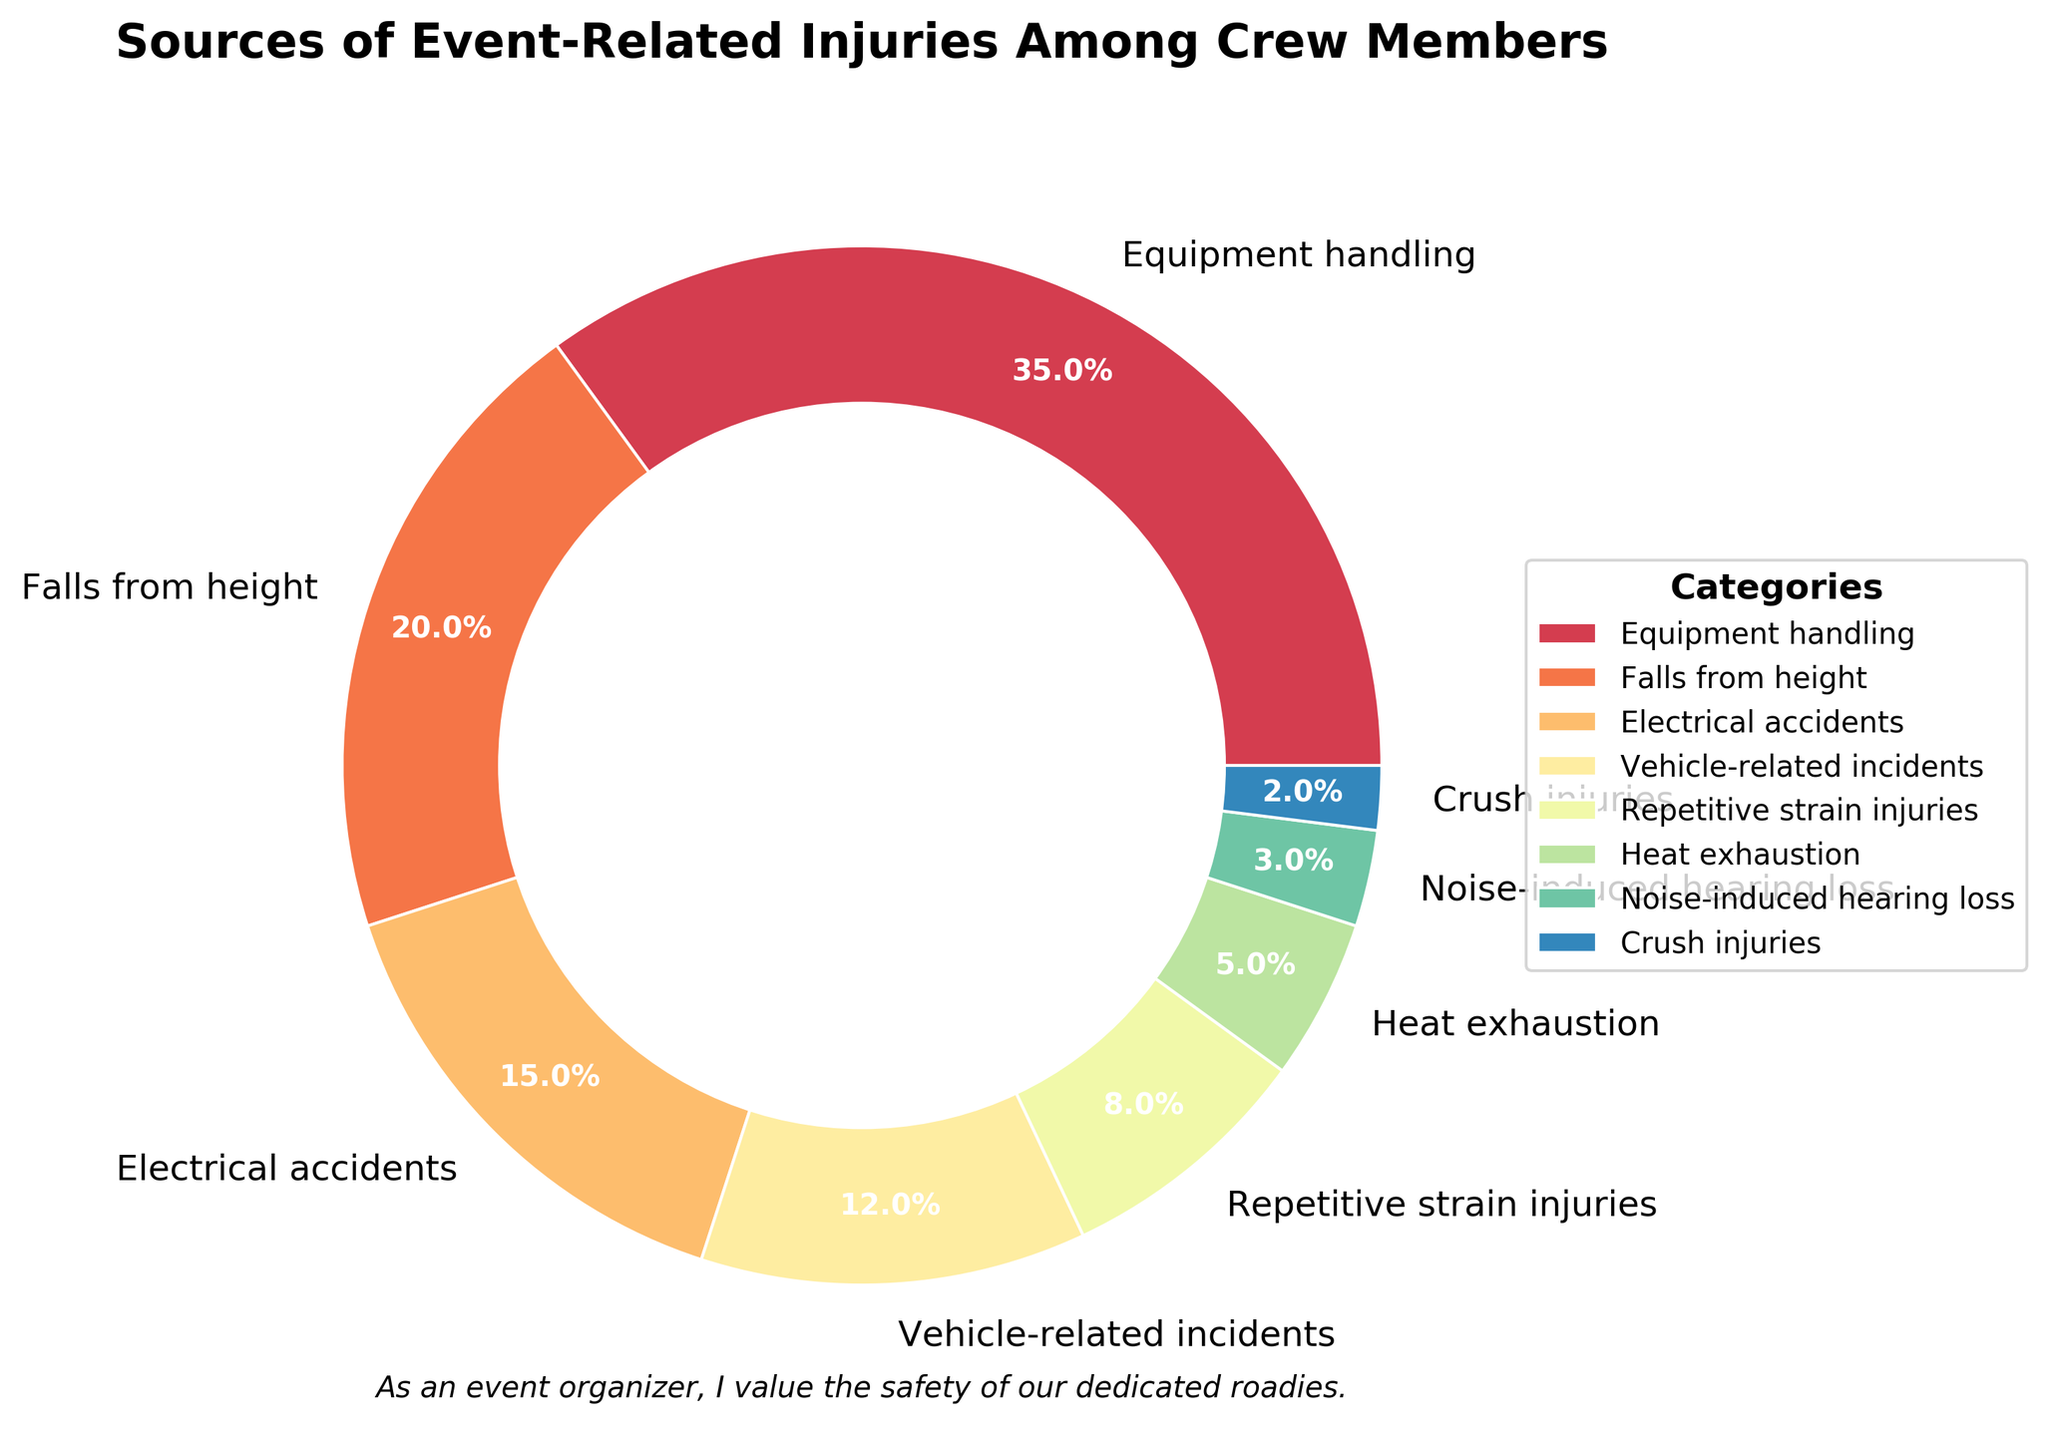What is the category with the highest percentage of event-related injuries among crew members? The pie chart shows that "Equipment handling" has the largest wedge, labeled with 35%. Thus, this category has the highest percentage of injuries.
Answer: Equipment handling Which two categories have the smallest percentages? By visually inspecting the pie chart, the wedges for "Crush injuries" and "Noise-induced hearing loss" are the smallest. They are labeled with 2% and 3% respectively, making them the smallest categories.
Answer: Crush injuries and Noise-induced hearing loss What is the combined percentage of "Falls from height" and "Electrical accidents"? The pie chart shows "Falls from height" at 20% and "Electrical accidents" at 15%. Adding these percentages gives 20% + 15% = 35%.
Answer: 35% Which category has a smaller percentage: "Heat exhaustion" or "Vehicle-related incidents"? Comparing the sizes of the wedges labeled "Heat exhaustion" and "Vehicle-related incidents," we see "Heat exhaustion" is 5% and "Vehicle-related incidents" is 12%. Therefore, "Heat exhaustion" has a smaller percentage.
Answer: Heat exhaustion What visual feature is used to separate each category in the pie chart? The pie chart uses white lines (edges) to separate each wedge or section. This feature clearly delineates the categories.
Answer: White lines (edges) What is the difference in percentage between "Repetitive strain injuries" and "Falls from height"? The pie chart labels "Repetitive strain injuries" at 8% and "Falls from height" at 20%. Subtracting the two percentages gives 20% - 8% = 12%.
Answer: 12% How does the chart visually emphasize the title and key message? The title is centrally located at the top in bold, large font. Additionally, a motivational message “As an event organizer, I value the safety of our dedicated roadies.” is placed at the bottom, emphasizing the key message visually.
Answer: Bold title and motivational message Which category has a percentage that is closest to the average percentage across all categories? First, calculate the average percentage by summing up all the percentages: 35 + 20 + 15 + 12 + 8 + 5 + 3 + 2 = 100. There are 8 categories, so the average is 100 / 8 = 12.5%. The category "Vehicle-related incidents" has a percentage of 12%, which is closest to 12.5%.
Answer: Vehicle-related incidents What is the total percentage of injuries from "Vehicle-related incidents," "Heat exhaustion," and "Noise-induced hearing loss"? According to the pie chart, the percentages are 12%, 5%, and 3% respectively. Adding these together results in 12% + 5% + 3% = 20%.
Answer: 20% Which category is represented by a wedge between "Falls from height" and "Vehicle-related incidents"? Visually inspecting the pie chart, "Electrical accidents" is situated between "Falls from height" (20%) and "Vehicle-related incidents" (12%).
Answer: Electrical accidents 